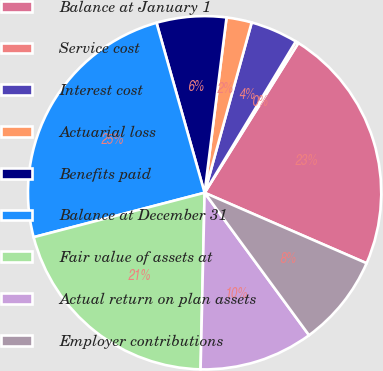Convert chart to OTSL. <chart><loc_0><loc_0><loc_500><loc_500><pie_chart><fcel>Balance at January 1<fcel>Service cost<fcel>Interest cost<fcel>Actuarial loss<fcel>Benefits paid<fcel>Balance at December 31<fcel>Fair value of assets at<fcel>Actual return on plan assets<fcel>Employer contributions<nl><fcel>22.63%<fcel>0.27%<fcel>4.34%<fcel>2.31%<fcel>6.37%<fcel>24.66%<fcel>20.59%<fcel>10.43%<fcel>8.4%<nl></chart> 